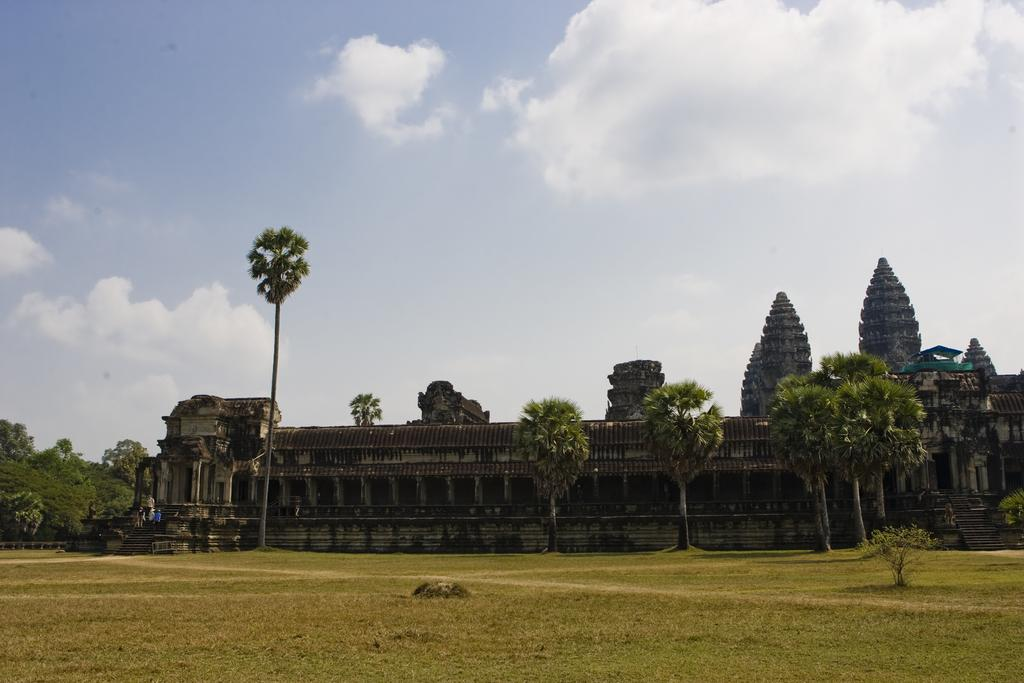What type of natural environment is visible in the image? There is grass and trees in the image, indicating a natural environment. What type of man-made structures can be seen in the image? Ancient architecture is present in the image. What is visible in the background of the image? The sky is visible in the background of the image. What can be observed in the sky? Clouds are present in the sky. How far away is the kitten from the ancient architecture in the image? There is no kitten present in the image, so it cannot be determined how far away it might be from the ancient architecture. 